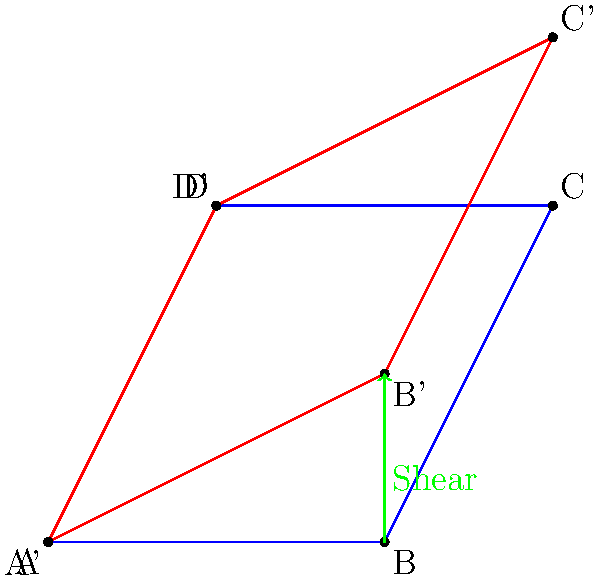Consider the parallelogram ABCD shown in blue, which represents the effect of a 2x2 matrix A on the unit square. The red parallelogram A'B'C'D' is the result of applying a shear transformation S to A. If the eigenvalues of A are $\lambda_1$ and $\lambda_2$, how does the shear transformation affect these eigenvalues? Provide a mathematical explanation for your answer. Let's approach this step-by-step:

1) First, recall that eigenvalues are invariant under similarity transformations. The shear transformation can be represented as a similarity transformation:

   $$S^{-1}AS = A'$$

   where A' is the matrix representing the sheared parallelogram.

2) The shear matrix S can be represented as:

   $$S = \begin{pmatrix} 1 & k \\ 0 & 1 \end{pmatrix}$$

   where k is the shear factor.

3) The inverse of S is:

   $$S^{-1} = \begin{pmatrix} 1 & -k \\ 0 & 1 \end{pmatrix}$$

4) Now, let's consider the characteristic equation of A':

   $$det(A' - \lambda I) = det(S^{-1}AS - \lambda I)$$

5) Using the properties of determinants:

   $$det(S^{-1}AS - \lambda I) = det(S^{-1}(A - \lambda I)S)$$

6) Again, using determinant properties:

   $$det(S^{-1}(A - \lambda I)S) = det(S^{-1})det(A - \lambda I)det(S)$$

7) Since $det(S) = det(S^{-1}) = 1$, we have:

   $$det(S^{-1})det(A - \lambda I)det(S) = det(A - \lambda I)$$

8) This means that the characteristic equation of A' is the same as that of A, implying that A and A' have the same eigenvalues.

Therefore, the shear transformation does not change the eigenvalues of the original matrix A. The eigenvalues remain $\lambda_1$ and $\lambda_2$.
Answer: The shear transformation does not change the eigenvalues; they remain $\lambda_1$ and $\lambda_2$. 